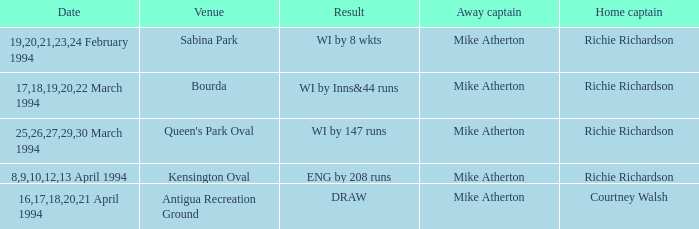Which Home Captain has Eng by 208 runs? Richie Richardson. 